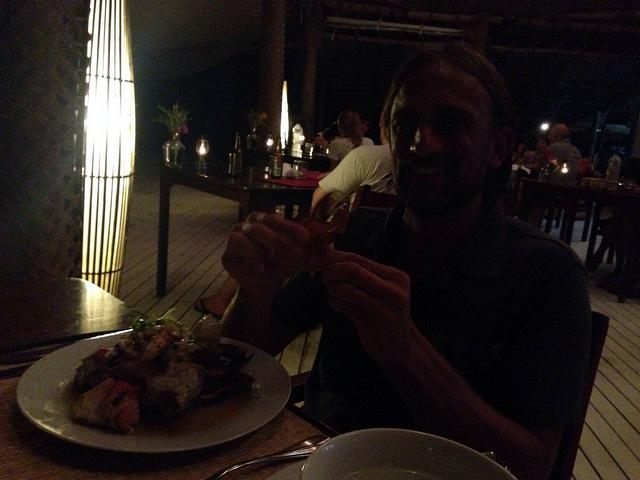What kind of food is the man consuming? seafood 